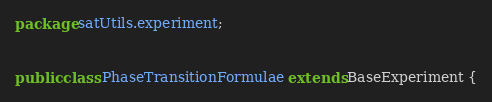Convert code to text. <code><loc_0><loc_0><loc_500><loc_500><_Java_>package satUtils.experiment;


public class PhaseTransitionFormulae extends BaseExperiment {</code> 